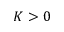Convert formula to latex. <formula><loc_0><loc_0><loc_500><loc_500>K > 0</formula> 